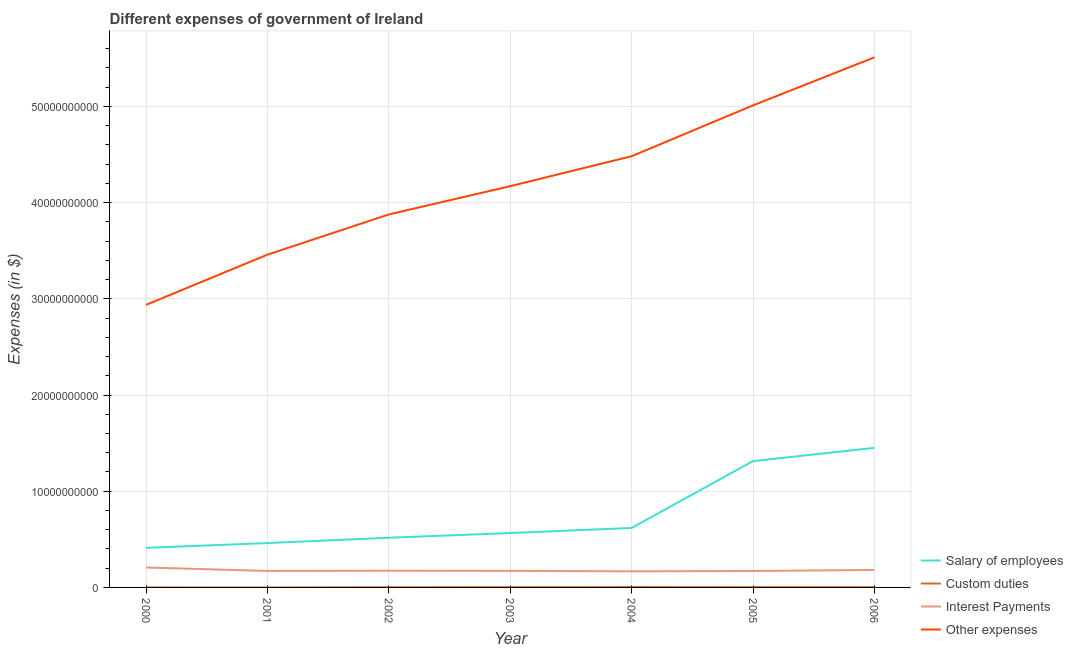Does the line corresponding to amount spent on other expenses intersect with the line corresponding to amount spent on interest payments?
Make the answer very short. No. What is the amount spent on interest payments in 2002?
Keep it short and to the point. 1.74e+09. Across all years, what is the maximum amount spent on other expenses?
Give a very brief answer. 5.51e+1. Across all years, what is the minimum amount spent on custom duties?
Make the answer very short. 0. In which year was the amount spent on custom duties maximum?
Offer a very short reply. 2004. What is the total amount spent on interest payments in the graph?
Keep it short and to the point. 1.24e+1. What is the difference between the amount spent on salary of employees in 2004 and that in 2006?
Provide a succinct answer. -8.32e+09. What is the difference between the amount spent on custom duties in 2002 and the amount spent on salary of employees in 2001?
Ensure brevity in your answer.  -4.60e+09. What is the average amount spent on interest payments per year?
Your answer should be very brief. 1.78e+09. In the year 2003, what is the difference between the amount spent on other expenses and amount spent on custom duties?
Give a very brief answer. 4.17e+1. What is the ratio of the amount spent on interest payments in 2001 to that in 2004?
Give a very brief answer. 1.03. What is the difference between the highest and the second highest amount spent on salary of employees?
Your answer should be very brief. 1.38e+09. What is the difference between the highest and the lowest amount spent on custom duties?
Ensure brevity in your answer.  3.67e+07. In how many years, is the amount spent on other expenses greater than the average amount spent on other expenses taken over all years?
Ensure brevity in your answer.  3. Is it the case that in every year, the sum of the amount spent on other expenses and amount spent on salary of employees is greater than the sum of amount spent on interest payments and amount spent on custom duties?
Provide a succinct answer. Yes. Is the amount spent on other expenses strictly less than the amount spent on interest payments over the years?
Ensure brevity in your answer.  No. What is the difference between two consecutive major ticks on the Y-axis?
Your response must be concise. 1.00e+1. Are the values on the major ticks of Y-axis written in scientific E-notation?
Offer a very short reply. No. Does the graph contain any zero values?
Your response must be concise. Yes. Does the graph contain grids?
Your answer should be very brief. Yes. What is the title of the graph?
Ensure brevity in your answer.  Different expenses of government of Ireland. Does "Structural Policies" appear as one of the legend labels in the graph?
Provide a short and direct response. No. What is the label or title of the Y-axis?
Give a very brief answer. Expenses (in $). What is the Expenses (in $) in Salary of employees in 2000?
Provide a short and direct response. 4.11e+09. What is the Expenses (in $) of Custom duties in 2000?
Provide a succinct answer. 0. What is the Expenses (in $) of Interest Payments in 2000?
Give a very brief answer. 2.07e+09. What is the Expenses (in $) of Other expenses in 2000?
Ensure brevity in your answer.  2.94e+1. What is the Expenses (in $) in Salary of employees in 2001?
Provide a short and direct response. 4.61e+09. What is the Expenses (in $) in Interest Payments in 2001?
Your answer should be very brief. 1.71e+09. What is the Expenses (in $) of Other expenses in 2001?
Provide a succinct answer. 3.46e+1. What is the Expenses (in $) of Salary of employees in 2002?
Provide a succinct answer. 5.16e+09. What is the Expenses (in $) of Custom duties in 2002?
Keep it short and to the point. 1.65e+07. What is the Expenses (in $) of Interest Payments in 2002?
Give a very brief answer. 1.74e+09. What is the Expenses (in $) in Other expenses in 2002?
Keep it short and to the point. 3.88e+1. What is the Expenses (in $) of Salary of employees in 2003?
Your response must be concise. 5.65e+09. What is the Expenses (in $) in Custom duties in 2003?
Offer a very short reply. 2.45e+07. What is the Expenses (in $) of Interest Payments in 2003?
Ensure brevity in your answer.  1.72e+09. What is the Expenses (in $) in Other expenses in 2003?
Make the answer very short. 4.17e+1. What is the Expenses (in $) in Salary of employees in 2004?
Your answer should be compact. 6.18e+09. What is the Expenses (in $) of Custom duties in 2004?
Provide a succinct answer. 3.67e+07. What is the Expenses (in $) of Interest Payments in 2004?
Keep it short and to the point. 1.67e+09. What is the Expenses (in $) in Other expenses in 2004?
Ensure brevity in your answer.  4.48e+1. What is the Expenses (in $) in Salary of employees in 2005?
Your answer should be compact. 1.31e+1. What is the Expenses (in $) of Custom duties in 2005?
Offer a very short reply. 3.06e+07. What is the Expenses (in $) of Interest Payments in 2005?
Your response must be concise. 1.71e+09. What is the Expenses (in $) in Other expenses in 2005?
Your answer should be compact. 5.01e+1. What is the Expenses (in $) of Salary of employees in 2006?
Give a very brief answer. 1.45e+1. What is the Expenses (in $) of Custom duties in 2006?
Offer a terse response. 3.44e+07. What is the Expenses (in $) of Interest Payments in 2006?
Keep it short and to the point. 1.82e+09. What is the Expenses (in $) of Other expenses in 2006?
Give a very brief answer. 5.51e+1. Across all years, what is the maximum Expenses (in $) of Salary of employees?
Your answer should be very brief. 1.45e+1. Across all years, what is the maximum Expenses (in $) of Custom duties?
Keep it short and to the point. 3.67e+07. Across all years, what is the maximum Expenses (in $) of Interest Payments?
Your answer should be compact. 2.07e+09. Across all years, what is the maximum Expenses (in $) of Other expenses?
Offer a terse response. 5.51e+1. Across all years, what is the minimum Expenses (in $) in Salary of employees?
Provide a succinct answer. 4.11e+09. Across all years, what is the minimum Expenses (in $) in Custom duties?
Your response must be concise. 0. Across all years, what is the minimum Expenses (in $) in Interest Payments?
Offer a very short reply. 1.67e+09. Across all years, what is the minimum Expenses (in $) in Other expenses?
Ensure brevity in your answer.  2.94e+1. What is the total Expenses (in $) in Salary of employees in the graph?
Offer a very short reply. 5.34e+1. What is the total Expenses (in $) of Custom duties in the graph?
Offer a terse response. 1.43e+08. What is the total Expenses (in $) of Interest Payments in the graph?
Provide a succinct answer. 1.24e+1. What is the total Expenses (in $) of Other expenses in the graph?
Ensure brevity in your answer.  2.94e+11. What is the difference between the Expenses (in $) of Salary of employees in 2000 and that in 2001?
Provide a short and direct response. -4.97e+08. What is the difference between the Expenses (in $) in Interest Payments in 2000 and that in 2001?
Give a very brief answer. 3.57e+08. What is the difference between the Expenses (in $) of Other expenses in 2000 and that in 2001?
Your answer should be compact. -5.22e+09. What is the difference between the Expenses (in $) in Salary of employees in 2000 and that in 2002?
Offer a terse response. -1.05e+09. What is the difference between the Expenses (in $) in Interest Payments in 2000 and that in 2002?
Offer a terse response. 3.35e+08. What is the difference between the Expenses (in $) of Other expenses in 2000 and that in 2002?
Keep it short and to the point. -9.40e+09. What is the difference between the Expenses (in $) of Salary of employees in 2000 and that in 2003?
Make the answer very short. -1.54e+09. What is the difference between the Expenses (in $) of Interest Payments in 2000 and that in 2003?
Give a very brief answer. 3.48e+08. What is the difference between the Expenses (in $) of Other expenses in 2000 and that in 2003?
Keep it short and to the point. -1.23e+1. What is the difference between the Expenses (in $) in Salary of employees in 2000 and that in 2004?
Make the answer very short. -2.07e+09. What is the difference between the Expenses (in $) in Interest Payments in 2000 and that in 2004?
Offer a terse response. 3.99e+08. What is the difference between the Expenses (in $) in Other expenses in 2000 and that in 2004?
Provide a short and direct response. -1.55e+1. What is the difference between the Expenses (in $) in Salary of employees in 2000 and that in 2005?
Offer a terse response. -9.02e+09. What is the difference between the Expenses (in $) in Interest Payments in 2000 and that in 2005?
Offer a terse response. 3.62e+08. What is the difference between the Expenses (in $) in Other expenses in 2000 and that in 2005?
Ensure brevity in your answer.  -2.07e+1. What is the difference between the Expenses (in $) in Salary of employees in 2000 and that in 2006?
Provide a succinct answer. -1.04e+1. What is the difference between the Expenses (in $) in Interest Payments in 2000 and that in 2006?
Your answer should be compact. 2.55e+08. What is the difference between the Expenses (in $) of Other expenses in 2000 and that in 2006?
Your response must be concise. -2.57e+1. What is the difference between the Expenses (in $) of Salary of employees in 2001 and that in 2002?
Provide a succinct answer. -5.53e+08. What is the difference between the Expenses (in $) in Interest Payments in 2001 and that in 2002?
Give a very brief answer. -2.20e+07. What is the difference between the Expenses (in $) in Other expenses in 2001 and that in 2002?
Your response must be concise. -4.18e+09. What is the difference between the Expenses (in $) in Salary of employees in 2001 and that in 2003?
Make the answer very short. -1.04e+09. What is the difference between the Expenses (in $) in Interest Payments in 2001 and that in 2003?
Offer a terse response. -8.74e+06. What is the difference between the Expenses (in $) in Other expenses in 2001 and that in 2003?
Your answer should be compact. -7.12e+09. What is the difference between the Expenses (in $) of Salary of employees in 2001 and that in 2004?
Your response must be concise. -1.57e+09. What is the difference between the Expenses (in $) of Interest Payments in 2001 and that in 2004?
Make the answer very short. 4.26e+07. What is the difference between the Expenses (in $) in Other expenses in 2001 and that in 2004?
Offer a very short reply. -1.02e+1. What is the difference between the Expenses (in $) in Salary of employees in 2001 and that in 2005?
Offer a very short reply. -8.52e+09. What is the difference between the Expenses (in $) of Interest Payments in 2001 and that in 2005?
Your answer should be compact. 4.69e+06. What is the difference between the Expenses (in $) in Other expenses in 2001 and that in 2005?
Provide a succinct answer. -1.55e+1. What is the difference between the Expenses (in $) in Salary of employees in 2001 and that in 2006?
Give a very brief answer. -9.90e+09. What is the difference between the Expenses (in $) in Interest Payments in 2001 and that in 2006?
Offer a terse response. -1.02e+08. What is the difference between the Expenses (in $) of Other expenses in 2001 and that in 2006?
Your answer should be very brief. -2.05e+1. What is the difference between the Expenses (in $) in Salary of employees in 2002 and that in 2003?
Ensure brevity in your answer.  -4.88e+08. What is the difference between the Expenses (in $) of Custom duties in 2002 and that in 2003?
Provide a short and direct response. -8.00e+06. What is the difference between the Expenses (in $) in Interest Payments in 2002 and that in 2003?
Offer a very short reply. 1.33e+07. What is the difference between the Expenses (in $) of Other expenses in 2002 and that in 2003?
Give a very brief answer. -2.94e+09. What is the difference between the Expenses (in $) of Salary of employees in 2002 and that in 2004?
Offer a terse response. -1.02e+09. What is the difference between the Expenses (in $) of Custom duties in 2002 and that in 2004?
Ensure brevity in your answer.  -2.02e+07. What is the difference between the Expenses (in $) of Interest Payments in 2002 and that in 2004?
Your answer should be compact. 6.46e+07. What is the difference between the Expenses (in $) of Other expenses in 2002 and that in 2004?
Keep it short and to the point. -6.05e+09. What is the difference between the Expenses (in $) in Salary of employees in 2002 and that in 2005?
Ensure brevity in your answer.  -7.97e+09. What is the difference between the Expenses (in $) in Custom duties in 2002 and that in 2005?
Your answer should be very brief. -1.41e+07. What is the difference between the Expenses (in $) in Interest Payments in 2002 and that in 2005?
Keep it short and to the point. 2.67e+07. What is the difference between the Expenses (in $) of Other expenses in 2002 and that in 2005?
Offer a terse response. -1.13e+1. What is the difference between the Expenses (in $) in Salary of employees in 2002 and that in 2006?
Make the answer very short. -9.34e+09. What is the difference between the Expenses (in $) of Custom duties in 2002 and that in 2006?
Keep it short and to the point. -1.79e+07. What is the difference between the Expenses (in $) in Interest Payments in 2002 and that in 2006?
Your answer should be compact. -8.00e+07. What is the difference between the Expenses (in $) in Other expenses in 2002 and that in 2006?
Your response must be concise. -1.63e+1. What is the difference between the Expenses (in $) in Salary of employees in 2003 and that in 2004?
Your answer should be compact. -5.31e+08. What is the difference between the Expenses (in $) in Custom duties in 2003 and that in 2004?
Your response must be concise. -1.22e+07. What is the difference between the Expenses (in $) in Interest Payments in 2003 and that in 2004?
Make the answer very short. 5.13e+07. What is the difference between the Expenses (in $) in Other expenses in 2003 and that in 2004?
Your answer should be compact. -3.11e+09. What is the difference between the Expenses (in $) of Salary of employees in 2003 and that in 2005?
Your answer should be compact. -7.48e+09. What is the difference between the Expenses (in $) of Custom duties in 2003 and that in 2005?
Your response must be concise. -6.12e+06. What is the difference between the Expenses (in $) of Interest Payments in 2003 and that in 2005?
Your answer should be very brief. 1.34e+07. What is the difference between the Expenses (in $) in Other expenses in 2003 and that in 2005?
Give a very brief answer. -8.40e+09. What is the difference between the Expenses (in $) in Salary of employees in 2003 and that in 2006?
Your response must be concise. -8.85e+09. What is the difference between the Expenses (in $) of Custom duties in 2003 and that in 2006?
Offer a very short reply. -9.89e+06. What is the difference between the Expenses (in $) of Interest Payments in 2003 and that in 2006?
Provide a short and direct response. -9.33e+07. What is the difference between the Expenses (in $) of Other expenses in 2003 and that in 2006?
Offer a very short reply. -1.34e+1. What is the difference between the Expenses (in $) of Salary of employees in 2004 and that in 2005?
Give a very brief answer. -6.95e+09. What is the difference between the Expenses (in $) of Custom duties in 2004 and that in 2005?
Offer a terse response. 6.12e+06. What is the difference between the Expenses (in $) of Interest Payments in 2004 and that in 2005?
Make the answer very short. -3.79e+07. What is the difference between the Expenses (in $) of Other expenses in 2004 and that in 2005?
Offer a very short reply. -5.29e+09. What is the difference between the Expenses (in $) of Salary of employees in 2004 and that in 2006?
Make the answer very short. -8.32e+09. What is the difference between the Expenses (in $) in Custom duties in 2004 and that in 2006?
Provide a short and direct response. 2.35e+06. What is the difference between the Expenses (in $) of Interest Payments in 2004 and that in 2006?
Your answer should be compact. -1.45e+08. What is the difference between the Expenses (in $) in Other expenses in 2004 and that in 2006?
Give a very brief answer. -1.03e+1. What is the difference between the Expenses (in $) in Salary of employees in 2005 and that in 2006?
Ensure brevity in your answer.  -1.38e+09. What is the difference between the Expenses (in $) in Custom duties in 2005 and that in 2006?
Provide a short and direct response. -3.77e+06. What is the difference between the Expenses (in $) in Interest Payments in 2005 and that in 2006?
Give a very brief answer. -1.07e+08. What is the difference between the Expenses (in $) in Other expenses in 2005 and that in 2006?
Your response must be concise. -4.99e+09. What is the difference between the Expenses (in $) in Salary of employees in 2000 and the Expenses (in $) in Interest Payments in 2001?
Offer a very short reply. 2.40e+09. What is the difference between the Expenses (in $) of Salary of employees in 2000 and the Expenses (in $) of Other expenses in 2001?
Your response must be concise. -3.05e+1. What is the difference between the Expenses (in $) of Interest Payments in 2000 and the Expenses (in $) of Other expenses in 2001?
Your response must be concise. -3.25e+1. What is the difference between the Expenses (in $) in Salary of employees in 2000 and the Expenses (in $) in Custom duties in 2002?
Keep it short and to the point. 4.10e+09. What is the difference between the Expenses (in $) of Salary of employees in 2000 and the Expenses (in $) of Interest Payments in 2002?
Offer a terse response. 2.38e+09. What is the difference between the Expenses (in $) in Salary of employees in 2000 and the Expenses (in $) in Other expenses in 2002?
Offer a terse response. -3.47e+1. What is the difference between the Expenses (in $) of Interest Payments in 2000 and the Expenses (in $) of Other expenses in 2002?
Give a very brief answer. -3.67e+1. What is the difference between the Expenses (in $) of Salary of employees in 2000 and the Expenses (in $) of Custom duties in 2003?
Your response must be concise. 4.09e+09. What is the difference between the Expenses (in $) of Salary of employees in 2000 and the Expenses (in $) of Interest Payments in 2003?
Your response must be concise. 2.39e+09. What is the difference between the Expenses (in $) in Salary of employees in 2000 and the Expenses (in $) in Other expenses in 2003?
Your response must be concise. -3.76e+1. What is the difference between the Expenses (in $) in Interest Payments in 2000 and the Expenses (in $) in Other expenses in 2003?
Make the answer very short. -3.96e+1. What is the difference between the Expenses (in $) in Salary of employees in 2000 and the Expenses (in $) in Custom duties in 2004?
Provide a short and direct response. 4.08e+09. What is the difference between the Expenses (in $) of Salary of employees in 2000 and the Expenses (in $) of Interest Payments in 2004?
Provide a short and direct response. 2.44e+09. What is the difference between the Expenses (in $) of Salary of employees in 2000 and the Expenses (in $) of Other expenses in 2004?
Make the answer very short. -4.07e+1. What is the difference between the Expenses (in $) in Interest Payments in 2000 and the Expenses (in $) in Other expenses in 2004?
Your response must be concise. -4.28e+1. What is the difference between the Expenses (in $) in Salary of employees in 2000 and the Expenses (in $) in Custom duties in 2005?
Provide a short and direct response. 4.08e+09. What is the difference between the Expenses (in $) in Salary of employees in 2000 and the Expenses (in $) in Interest Payments in 2005?
Provide a succinct answer. 2.40e+09. What is the difference between the Expenses (in $) in Salary of employees in 2000 and the Expenses (in $) in Other expenses in 2005?
Provide a short and direct response. -4.60e+1. What is the difference between the Expenses (in $) of Interest Payments in 2000 and the Expenses (in $) of Other expenses in 2005?
Provide a succinct answer. -4.80e+1. What is the difference between the Expenses (in $) of Salary of employees in 2000 and the Expenses (in $) of Custom duties in 2006?
Provide a short and direct response. 4.08e+09. What is the difference between the Expenses (in $) of Salary of employees in 2000 and the Expenses (in $) of Interest Payments in 2006?
Your response must be concise. 2.30e+09. What is the difference between the Expenses (in $) in Salary of employees in 2000 and the Expenses (in $) in Other expenses in 2006?
Offer a terse response. -5.10e+1. What is the difference between the Expenses (in $) in Interest Payments in 2000 and the Expenses (in $) in Other expenses in 2006?
Your answer should be very brief. -5.30e+1. What is the difference between the Expenses (in $) in Salary of employees in 2001 and the Expenses (in $) in Custom duties in 2002?
Your answer should be compact. 4.60e+09. What is the difference between the Expenses (in $) of Salary of employees in 2001 and the Expenses (in $) of Interest Payments in 2002?
Your response must be concise. 2.88e+09. What is the difference between the Expenses (in $) in Salary of employees in 2001 and the Expenses (in $) in Other expenses in 2002?
Keep it short and to the point. -3.42e+1. What is the difference between the Expenses (in $) of Interest Payments in 2001 and the Expenses (in $) of Other expenses in 2002?
Give a very brief answer. -3.71e+1. What is the difference between the Expenses (in $) in Salary of employees in 2001 and the Expenses (in $) in Custom duties in 2003?
Your answer should be compact. 4.59e+09. What is the difference between the Expenses (in $) of Salary of employees in 2001 and the Expenses (in $) of Interest Payments in 2003?
Give a very brief answer. 2.89e+09. What is the difference between the Expenses (in $) of Salary of employees in 2001 and the Expenses (in $) of Other expenses in 2003?
Give a very brief answer. -3.71e+1. What is the difference between the Expenses (in $) in Interest Payments in 2001 and the Expenses (in $) in Other expenses in 2003?
Ensure brevity in your answer.  -4.00e+1. What is the difference between the Expenses (in $) of Salary of employees in 2001 and the Expenses (in $) of Custom duties in 2004?
Keep it short and to the point. 4.58e+09. What is the difference between the Expenses (in $) of Salary of employees in 2001 and the Expenses (in $) of Interest Payments in 2004?
Give a very brief answer. 2.94e+09. What is the difference between the Expenses (in $) in Salary of employees in 2001 and the Expenses (in $) in Other expenses in 2004?
Offer a very short reply. -4.02e+1. What is the difference between the Expenses (in $) of Interest Payments in 2001 and the Expenses (in $) of Other expenses in 2004?
Keep it short and to the point. -4.31e+1. What is the difference between the Expenses (in $) in Salary of employees in 2001 and the Expenses (in $) in Custom duties in 2005?
Make the answer very short. 4.58e+09. What is the difference between the Expenses (in $) of Salary of employees in 2001 and the Expenses (in $) of Interest Payments in 2005?
Your answer should be very brief. 2.90e+09. What is the difference between the Expenses (in $) of Salary of employees in 2001 and the Expenses (in $) of Other expenses in 2005?
Give a very brief answer. -4.55e+1. What is the difference between the Expenses (in $) of Interest Payments in 2001 and the Expenses (in $) of Other expenses in 2005?
Give a very brief answer. -4.84e+1. What is the difference between the Expenses (in $) in Salary of employees in 2001 and the Expenses (in $) in Custom duties in 2006?
Provide a short and direct response. 4.58e+09. What is the difference between the Expenses (in $) of Salary of employees in 2001 and the Expenses (in $) of Interest Payments in 2006?
Offer a terse response. 2.80e+09. What is the difference between the Expenses (in $) of Salary of employees in 2001 and the Expenses (in $) of Other expenses in 2006?
Your answer should be compact. -5.05e+1. What is the difference between the Expenses (in $) of Interest Payments in 2001 and the Expenses (in $) of Other expenses in 2006?
Offer a terse response. -5.34e+1. What is the difference between the Expenses (in $) in Salary of employees in 2002 and the Expenses (in $) in Custom duties in 2003?
Offer a terse response. 5.14e+09. What is the difference between the Expenses (in $) of Salary of employees in 2002 and the Expenses (in $) of Interest Payments in 2003?
Your answer should be very brief. 3.44e+09. What is the difference between the Expenses (in $) of Salary of employees in 2002 and the Expenses (in $) of Other expenses in 2003?
Make the answer very short. -3.65e+1. What is the difference between the Expenses (in $) in Custom duties in 2002 and the Expenses (in $) in Interest Payments in 2003?
Ensure brevity in your answer.  -1.71e+09. What is the difference between the Expenses (in $) in Custom duties in 2002 and the Expenses (in $) in Other expenses in 2003?
Your answer should be compact. -4.17e+1. What is the difference between the Expenses (in $) in Interest Payments in 2002 and the Expenses (in $) in Other expenses in 2003?
Offer a terse response. -4.00e+1. What is the difference between the Expenses (in $) of Salary of employees in 2002 and the Expenses (in $) of Custom duties in 2004?
Ensure brevity in your answer.  5.13e+09. What is the difference between the Expenses (in $) of Salary of employees in 2002 and the Expenses (in $) of Interest Payments in 2004?
Provide a short and direct response. 3.49e+09. What is the difference between the Expenses (in $) of Salary of employees in 2002 and the Expenses (in $) of Other expenses in 2004?
Provide a succinct answer. -3.97e+1. What is the difference between the Expenses (in $) in Custom duties in 2002 and the Expenses (in $) in Interest Payments in 2004?
Your response must be concise. -1.66e+09. What is the difference between the Expenses (in $) of Custom duties in 2002 and the Expenses (in $) of Other expenses in 2004?
Ensure brevity in your answer.  -4.48e+1. What is the difference between the Expenses (in $) in Interest Payments in 2002 and the Expenses (in $) in Other expenses in 2004?
Provide a succinct answer. -4.31e+1. What is the difference between the Expenses (in $) of Salary of employees in 2002 and the Expenses (in $) of Custom duties in 2005?
Make the answer very short. 5.13e+09. What is the difference between the Expenses (in $) of Salary of employees in 2002 and the Expenses (in $) of Interest Payments in 2005?
Your answer should be compact. 3.45e+09. What is the difference between the Expenses (in $) in Salary of employees in 2002 and the Expenses (in $) in Other expenses in 2005?
Offer a terse response. -4.49e+1. What is the difference between the Expenses (in $) in Custom duties in 2002 and the Expenses (in $) in Interest Payments in 2005?
Offer a terse response. -1.69e+09. What is the difference between the Expenses (in $) of Custom duties in 2002 and the Expenses (in $) of Other expenses in 2005?
Ensure brevity in your answer.  -5.01e+1. What is the difference between the Expenses (in $) of Interest Payments in 2002 and the Expenses (in $) of Other expenses in 2005?
Your response must be concise. -4.84e+1. What is the difference between the Expenses (in $) of Salary of employees in 2002 and the Expenses (in $) of Custom duties in 2006?
Keep it short and to the point. 5.13e+09. What is the difference between the Expenses (in $) in Salary of employees in 2002 and the Expenses (in $) in Interest Payments in 2006?
Offer a very short reply. 3.35e+09. What is the difference between the Expenses (in $) of Salary of employees in 2002 and the Expenses (in $) of Other expenses in 2006?
Ensure brevity in your answer.  -4.99e+1. What is the difference between the Expenses (in $) of Custom duties in 2002 and the Expenses (in $) of Interest Payments in 2006?
Your answer should be compact. -1.80e+09. What is the difference between the Expenses (in $) of Custom duties in 2002 and the Expenses (in $) of Other expenses in 2006?
Offer a terse response. -5.51e+1. What is the difference between the Expenses (in $) in Interest Payments in 2002 and the Expenses (in $) in Other expenses in 2006?
Provide a succinct answer. -5.34e+1. What is the difference between the Expenses (in $) of Salary of employees in 2003 and the Expenses (in $) of Custom duties in 2004?
Your answer should be compact. 5.62e+09. What is the difference between the Expenses (in $) in Salary of employees in 2003 and the Expenses (in $) in Interest Payments in 2004?
Keep it short and to the point. 3.98e+09. What is the difference between the Expenses (in $) of Salary of employees in 2003 and the Expenses (in $) of Other expenses in 2004?
Ensure brevity in your answer.  -3.92e+1. What is the difference between the Expenses (in $) in Custom duties in 2003 and the Expenses (in $) in Interest Payments in 2004?
Give a very brief answer. -1.65e+09. What is the difference between the Expenses (in $) of Custom duties in 2003 and the Expenses (in $) of Other expenses in 2004?
Provide a short and direct response. -4.48e+1. What is the difference between the Expenses (in $) in Interest Payments in 2003 and the Expenses (in $) in Other expenses in 2004?
Provide a short and direct response. -4.31e+1. What is the difference between the Expenses (in $) in Salary of employees in 2003 and the Expenses (in $) in Custom duties in 2005?
Offer a terse response. 5.62e+09. What is the difference between the Expenses (in $) of Salary of employees in 2003 and the Expenses (in $) of Interest Payments in 2005?
Provide a succinct answer. 3.94e+09. What is the difference between the Expenses (in $) of Salary of employees in 2003 and the Expenses (in $) of Other expenses in 2005?
Offer a very short reply. -4.45e+1. What is the difference between the Expenses (in $) of Custom duties in 2003 and the Expenses (in $) of Interest Payments in 2005?
Make the answer very short. -1.69e+09. What is the difference between the Expenses (in $) of Custom duties in 2003 and the Expenses (in $) of Other expenses in 2005?
Provide a succinct answer. -5.01e+1. What is the difference between the Expenses (in $) of Interest Payments in 2003 and the Expenses (in $) of Other expenses in 2005?
Make the answer very short. -4.84e+1. What is the difference between the Expenses (in $) in Salary of employees in 2003 and the Expenses (in $) in Custom duties in 2006?
Make the answer very short. 5.62e+09. What is the difference between the Expenses (in $) of Salary of employees in 2003 and the Expenses (in $) of Interest Payments in 2006?
Give a very brief answer. 3.84e+09. What is the difference between the Expenses (in $) of Salary of employees in 2003 and the Expenses (in $) of Other expenses in 2006?
Provide a succinct answer. -4.95e+1. What is the difference between the Expenses (in $) in Custom duties in 2003 and the Expenses (in $) in Interest Payments in 2006?
Offer a terse response. -1.79e+09. What is the difference between the Expenses (in $) in Custom duties in 2003 and the Expenses (in $) in Other expenses in 2006?
Offer a terse response. -5.51e+1. What is the difference between the Expenses (in $) of Interest Payments in 2003 and the Expenses (in $) of Other expenses in 2006?
Provide a succinct answer. -5.34e+1. What is the difference between the Expenses (in $) in Salary of employees in 2004 and the Expenses (in $) in Custom duties in 2005?
Your response must be concise. 6.15e+09. What is the difference between the Expenses (in $) of Salary of employees in 2004 and the Expenses (in $) of Interest Payments in 2005?
Keep it short and to the point. 4.47e+09. What is the difference between the Expenses (in $) of Salary of employees in 2004 and the Expenses (in $) of Other expenses in 2005?
Provide a succinct answer. -4.39e+1. What is the difference between the Expenses (in $) of Custom duties in 2004 and the Expenses (in $) of Interest Payments in 2005?
Your response must be concise. -1.67e+09. What is the difference between the Expenses (in $) in Custom duties in 2004 and the Expenses (in $) in Other expenses in 2005?
Your response must be concise. -5.01e+1. What is the difference between the Expenses (in $) in Interest Payments in 2004 and the Expenses (in $) in Other expenses in 2005?
Provide a short and direct response. -4.84e+1. What is the difference between the Expenses (in $) in Salary of employees in 2004 and the Expenses (in $) in Custom duties in 2006?
Ensure brevity in your answer.  6.15e+09. What is the difference between the Expenses (in $) in Salary of employees in 2004 and the Expenses (in $) in Interest Payments in 2006?
Make the answer very short. 4.37e+09. What is the difference between the Expenses (in $) in Salary of employees in 2004 and the Expenses (in $) in Other expenses in 2006?
Keep it short and to the point. -4.89e+1. What is the difference between the Expenses (in $) in Custom duties in 2004 and the Expenses (in $) in Interest Payments in 2006?
Your answer should be compact. -1.78e+09. What is the difference between the Expenses (in $) in Custom duties in 2004 and the Expenses (in $) in Other expenses in 2006?
Offer a very short reply. -5.51e+1. What is the difference between the Expenses (in $) of Interest Payments in 2004 and the Expenses (in $) of Other expenses in 2006?
Provide a succinct answer. -5.34e+1. What is the difference between the Expenses (in $) in Salary of employees in 2005 and the Expenses (in $) in Custom duties in 2006?
Give a very brief answer. 1.31e+1. What is the difference between the Expenses (in $) in Salary of employees in 2005 and the Expenses (in $) in Interest Payments in 2006?
Keep it short and to the point. 1.13e+1. What is the difference between the Expenses (in $) in Salary of employees in 2005 and the Expenses (in $) in Other expenses in 2006?
Your answer should be compact. -4.20e+1. What is the difference between the Expenses (in $) of Custom duties in 2005 and the Expenses (in $) of Interest Payments in 2006?
Offer a terse response. -1.79e+09. What is the difference between the Expenses (in $) of Custom duties in 2005 and the Expenses (in $) of Other expenses in 2006?
Offer a very short reply. -5.51e+1. What is the difference between the Expenses (in $) of Interest Payments in 2005 and the Expenses (in $) of Other expenses in 2006?
Provide a succinct answer. -5.34e+1. What is the average Expenses (in $) of Salary of employees per year?
Provide a short and direct response. 7.62e+09. What is the average Expenses (in $) of Custom duties per year?
Your answer should be compact. 2.04e+07. What is the average Expenses (in $) in Interest Payments per year?
Keep it short and to the point. 1.78e+09. What is the average Expenses (in $) of Other expenses per year?
Keep it short and to the point. 4.21e+1. In the year 2000, what is the difference between the Expenses (in $) of Salary of employees and Expenses (in $) of Interest Payments?
Ensure brevity in your answer.  2.04e+09. In the year 2000, what is the difference between the Expenses (in $) of Salary of employees and Expenses (in $) of Other expenses?
Your response must be concise. -2.53e+1. In the year 2000, what is the difference between the Expenses (in $) of Interest Payments and Expenses (in $) of Other expenses?
Provide a succinct answer. -2.73e+1. In the year 2001, what is the difference between the Expenses (in $) of Salary of employees and Expenses (in $) of Interest Payments?
Offer a very short reply. 2.90e+09. In the year 2001, what is the difference between the Expenses (in $) in Salary of employees and Expenses (in $) in Other expenses?
Ensure brevity in your answer.  -3.00e+1. In the year 2001, what is the difference between the Expenses (in $) in Interest Payments and Expenses (in $) in Other expenses?
Keep it short and to the point. -3.29e+1. In the year 2002, what is the difference between the Expenses (in $) of Salary of employees and Expenses (in $) of Custom duties?
Your answer should be very brief. 5.15e+09. In the year 2002, what is the difference between the Expenses (in $) in Salary of employees and Expenses (in $) in Interest Payments?
Provide a short and direct response. 3.43e+09. In the year 2002, what is the difference between the Expenses (in $) of Salary of employees and Expenses (in $) of Other expenses?
Provide a succinct answer. -3.36e+1. In the year 2002, what is the difference between the Expenses (in $) of Custom duties and Expenses (in $) of Interest Payments?
Provide a short and direct response. -1.72e+09. In the year 2002, what is the difference between the Expenses (in $) in Custom duties and Expenses (in $) in Other expenses?
Give a very brief answer. -3.88e+1. In the year 2002, what is the difference between the Expenses (in $) of Interest Payments and Expenses (in $) of Other expenses?
Keep it short and to the point. -3.70e+1. In the year 2003, what is the difference between the Expenses (in $) of Salary of employees and Expenses (in $) of Custom duties?
Your answer should be very brief. 5.63e+09. In the year 2003, what is the difference between the Expenses (in $) in Salary of employees and Expenses (in $) in Interest Payments?
Give a very brief answer. 3.93e+09. In the year 2003, what is the difference between the Expenses (in $) in Salary of employees and Expenses (in $) in Other expenses?
Your answer should be very brief. -3.61e+1. In the year 2003, what is the difference between the Expenses (in $) in Custom duties and Expenses (in $) in Interest Payments?
Keep it short and to the point. -1.70e+09. In the year 2003, what is the difference between the Expenses (in $) of Custom duties and Expenses (in $) of Other expenses?
Keep it short and to the point. -4.17e+1. In the year 2003, what is the difference between the Expenses (in $) of Interest Payments and Expenses (in $) of Other expenses?
Provide a succinct answer. -4.00e+1. In the year 2004, what is the difference between the Expenses (in $) in Salary of employees and Expenses (in $) in Custom duties?
Provide a succinct answer. 6.15e+09. In the year 2004, what is the difference between the Expenses (in $) in Salary of employees and Expenses (in $) in Interest Payments?
Make the answer very short. 4.51e+09. In the year 2004, what is the difference between the Expenses (in $) of Salary of employees and Expenses (in $) of Other expenses?
Ensure brevity in your answer.  -3.86e+1. In the year 2004, what is the difference between the Expenses (in $) in Custom duties and Expenses (in $) in Interest Payments?
Offer a terse response. -1.64e+09. In the year 2004, what is the difference between the Expenses (in $) in Custom duties and Expenses (in $) in Other expenses?
Your answer should be compact. -4.48e+1. In the year 2004, what is the difference between the Expenses (in $) of Interest Payments and Expenses (in $) of Other expenses?
Provide a short and direct response. -4.32e+1. In the year 2005, what is the difference between the Expenses (in $) of Salary of employees and Expenses (in $) of Custom duties?
Provide a succinct answer. 1.31e+1. In the year 2005, what is the difference between the Expenses (in $) of Salary of employees and Expenses (in $) of Interest Payments?
Offer a terse response. 1.14e+1. In the year 2005, what is the difference between the Expenses (in $) in Salary of employees and Expenses (in $) in Other expenses?
Give a very brief answer. -3.70e+1. In the year 2005, what is the difference between the Expenses (in $) of Custom duties and Expenses (in $) of Interest Payments?
Provide a short and direct response. -1.68e+09. In the year 2005, what is the difference between the Expenses (in $) of Custom duties and Expenses (in $) of Other expenses?
Give a very brief answer. -5.01e+1. In the year 2005, what is the difference between the Expenses (in $) of Interest Payments and Expenses (in $) of Other expenses?
Your response must be concise. -4.84e+1. In the year 2006, what is the difference between the Expenses (in $) of Salary of employees and Expenses (in $) of Custom duties?
Offer a terse response. 1.45e+1. In the year 2006, what is the difference between the Expenses (in $) in Salary of employees and Expenses (in $) in Interest Payments?
Your answer should be very brief. 1.27e+1. In the year 2006, what is the difference between the Expenses (in $) in Salary of employees and Expenses (in $) in Other expenses?
Your answer should be very brief. -4.06e+1. In the year 2006, what is the difference between the Expenses (in $) in Custom duties and Expenses (in $) in Interest Payments?
Give a very brief answer. -1.78e+09. In the year 2006, what is the difference between the Expenses (in $) in Custom duties and Expenses (in $) in Other expenses?
Provide a short and direct response. -5.51e+1. In the year 2006, what is the difference between the Expenses (in $) of Interest Payments and Expenses (in $) of Other expenses?
Provide a succinct answer. -5.33e+1. What is the ratio of the Expenses (in $) of Salary of employees in 2000 to that in 2001?
Your answer should be compact. 0.89. What is the ratio of the Expenses (in $) of Interest Payments in 2000 to that in 2001?
Offer a very short reply. 1.21. What is the ratio of the Expenses (in $) of Other expenses in 2000 to that in 2001?
Offer a very short reply. 0.85. What is the ratio of the Expenses (in $) in Salary of employees in 2000 to that in 2002?
Offer a very short reply. 0.8. What is the ratio of the Expenses (in $) in Interest Payments in 2000 to that in 2002?
Make the answer very short. 1.19. What is the ratio of the Expenses (in $) in Other expenses in 2000 to that in 2002?
Provide a short and direct response. 0.76. What is the ratio of the Expenses (in $) of Salary of employees in 2000 to that in 2003?
Provide a succinct answer. 0.73. What is the ratio of the Expenses (in $) of Interest Payments in 2000 to that in 2003?
Provide a succinct answer. 1.2. What is the ratio of the Expenses (in $) in Other expenses in 2000 to that in 2003?
Offer a very short reply. 0.7. What is the ratio of the Expenses (in $) in Salary of employees in 2000 to that in 2004?
Offer a very short reply. 0.67. What is the ratio of the Expenses (in $) of Interest Payments in 2000 to that in 2004?
Ensure brevity in your answer.  1.24. What is the ratio of the Expenses (in $) of Other expenses in 2000 to that in 2004?
Your answer should be very brief. 0.66. What is the ratio of the Expenses (in $) of Salary of employees in 2000 to that in 2005?
Provide a succinct answer. 0.31. What is the ratio of the Expenses (in $) in Interest Payments in 2000 to that in 2005?
Offer a terse response. 1.21. What is the ratio of the Expenses (in $) in Other expenses in 2000 to that in 2005?
Offer a very short reply. 0.59. What is the ratio of the Expenses (in $) of Salary of employees in 2000 to that in 2006?
Make the answer very short. 0.28. What is the ratio of the Expenses (in $) in Interest Payments in 2000 to that in 2006?
Your answer should be compact. 1.14. What is the ratio of the Expenses (in $) of Other expenses in 2000 to that in 2006?
Give a very brief answer. 0.53. What is the ratio of the Expenses (in $) of Salary of employees in 2001 to that in 2002?
Your response must be concise. 0.89. What is the ratio of the Expenses (in $) in Interest Payments in 2001 to that in 2002?
Your answer should be compact. 0.99. What is the ratio of the Expenses (in $) of Other expenses in 2001 to that in 2002?
Offer a very short reply. 0.89. What is the ratio of the Expenses (in $) of Salary of employees in 2001 to that in 2003?
Offer a very short reply. 0.82. What is the ratio of the Expenses (in $) of Interest Payments in 2001 to that in 2003?
Keep it short and to the point. 0.99. What is the ratio of the Expenses (in $) of Other expenses in 2001 to that in 2003?
Provide a short and direct response. 0.83. What is the ratio of the Expenses (in $) in Salary of employees in 2001 to that in 2004?
Your answer should be very brief. 0.75. What is the ratio of the Expenses (in $) in Interest Payments in 2001 to that in 2004?
Give a very brief answer. 1.03. What is the ratio of the Expenses (in $) of Other expenses in 2001 to that in 2004?
Your answer should be very brief. 0.77. What is the ratio of the Expenses (in $) of Salary of employees in 2001 to that in 2005?
Your answer should be compact. 0.35. What is the ratio of the Expenses (in $) of Interest Payments in 2001 to that in 2005?
Keep it short and to the point. 1. What is the ratio of the Expenses (in $) in Other expenses in 2001 to that in 2005?
Offer a very short reply. 0.69. What is the ratio of the Expenses (in $) in Salary of employees in 2001 to that in 2006?
Keep it short and to the point. 0.32. What is the ratio of the Expenses (in $) in Interest Payments in 2001 to that in 2006?
Keep it short and to the point. 0.94. What is the ratio of the Expenses (in $) of Other expenses in 2001 to that in 2006?
Make the answer very short. 0.63. What is the ratio of the Expenses (in $) of Salary of employees in 2002 to that in 2003?
Ensure brevity in your answer.  0.91. What is the ratio of the Expenses (in $) of Custom duties in 2002 to that in 2003?
Offer a very short reply. 0.67. What is the ratio of the Expenses (in $) of Interest Payments in 2002 to that in 2003?
Provide a succinct answer. 1.01. What is the ratio of the Expenses (in $) in Other expenses in 2002 to that in 2003?
Your response must be concise. 0.93. What is the ratio of the Expenses (in $) of Salary of employees in 2002 to that in 2004?
Your response must be concise. 0.84. What is the ratio of the Expenses (in $) in Custom duties in 2002 to that in 2004?
Keep it short and to the point. 0.45. What is the ratio of the Expenses (in $) in Interest Payments in 2002 to that in 2004?
Provide a short and direct response. 1.04. What is the ratio of the Expenses (in $) of Other expenses in 2002 to that in 2004?
Provide a succinct answer. 0.86. What is the ratio of the Expenses (in $) of Salary of employees in 2002 to that in 2005?
Offer a terse response. 0.39. What is the ratio of the Expenses (in $) in Custom duties in 2002 to that in 2005?
Offer a terse response. 0.54. What is the ratio of the Expenses (in $) of Interest Payments in 2002 to that in 2005?
Provide a short and direct response. 1.02. What is the ratio of the Expenses (in $) in Other expenses in 2002 to that in 2005?
Give a very brief answer. 0.77. What is the ratio of the Expenses (in $) of Salary of employees in 2002 to that in 2006?
Your response must be concise. 0.36. What is the ratio of the Expenses (in $) of Custom duties in 2002 to that in 2006?
Give a very brief answer. 0.48. What is the ratio of the Expenses (in $) of Interest Payments in 2002 to that in 2006?
Give a very brief answer. 0.96. What is the ratio of the Expenses (in $) of Other expenses in 2002 to that in 2006?
Your answer should be compact. 0.7. What is the ratio of the Expenses (in $) of Salary of employees in 2003 to that in 2004?
Offer a very short reply. 0.91. What is the ratio of the Expenses (in $) of Custom duties in 2003 to that in 2004?
Your answer should be compact. 0.67. What is the ratio of the Expenses (in $) in Interest Payments in 2003 to that in 2004?
Your answer should be compact. 1.03. What is the ratio of the Expenses (in $) in Other expenses in 2003 to that in 2004?
Offer a terse response. 0.93. What is the ratio of the Expenses (in $) of Salary of employees in 2003 to that in 2005?
Provide a short and direct response. 0.43. What is the ratio of the Expenses (in $) of Custom duties in 2003 to that in 2005?
Keep it short and to the point. 0.8. What is the ratio of the Expenses (in $) of Interest Payments in 2003 to that in 2005?
Make the answer very short. 1.01. What is the ratio of the Expenses (in $) of Other expenses in 2003 to that in 2005?
Offer a terse response. 0.83. What is the ratio of the Expenses (in $) of Salary of employees in 2003 to that in 2006?
Offer a terse response. 0.39. What is the ratio of the Expenses (in $) of Custom duties in 2003 to that in 2006?
Provide a short and direct response. 0.71. What is the ratio of the Expenses (in $) in Interest Payments in 2003 to that in 2006?
Ensure brevity in your answer.  0.95. What is the ratio of the Expenses (in $) of Other expenses in 2003 to that in 2006?
Your answer should be compact. 0.76. What is the ratio of the Expenses (in $) in Salary of employees in 2004 to that in 2005?
Your answer should be compact. 0.47. What is the ratio of the Expenses (in $) in Custom duties in 2004 to that in 2005?
Ensure brevity in your answer.  1.2. What is the ratio of the Expenses (in $) in Interest Payments in 2004 to that in 2005?
Your answer should be compact. 0.98. What is the ratio of the Expenses (in $) of Other expenses in 2004 to that in 2005?
Provide a succinct answer. 0.89. What is the ratio of the Expenses (in $) in Salary of employees in 2004 to that in 2006?
Provide a short and direct response. 0.43. What is the ratio of the Expenses (in $) of Custom duties in 2004 to that in 2006?
Offer a very short reply. 1.07. What is the ratio of the Expenses (in $) in Interest Payments in 2004 to that in 2006?
Your answer should be very brief. 0.92. What is the ratio of the Expenses (in $) of Other expenses in 2004 to that in 2006?
Provide a short and direct response. 0.81. What is the ratio of the Expenses (in $) in Salary of employees in 2005 to that in 2006?
Offer a terse response. 0.91. What is the ratio of the Expenses (in $) of Custom duties in 2005 to that in 2006?
Provide a succinct answer. 0.89. What is the ratio of the Expenses (in $) of Other expenses in 2005 to that in 2006?
Give a very brief answer. 0.91. What is the difference between the highest and the second highest Expenses (in $) of Salary of employees?
Give a very brief answer. 1.38e+09. What is the difference between the highest and the second highest Expenses (in $) of Custom duties?
Offer a very short reply. 2.35e+06. What is the difference between the highest and the second highest Expenses (in $) of Interest Payments?
Ensure brevity in your answer.  2.55e+08. What is the difference between the highest and the second highest Expenses (in $) of Other expenses?
Your response must be concise. 4.99e+09. What is the difference between the highest and the lowest Expenses (in $) in Salary of employees?
Provide a short and direct response. 1.04e+1. What is the difference between the highest and the lowest Expenses (in $) in Custom duties?
Offer a very short reply. 3.67e+07. What is the difference between the highest and the lowest Expenses (in $) in Interest Payments?
Make the answer very short. 3.99e+08. What is the difference between the highest and the lowest Expenses (in $) of Other expenses?
Your answer should be very brief. 2.57e+1. 